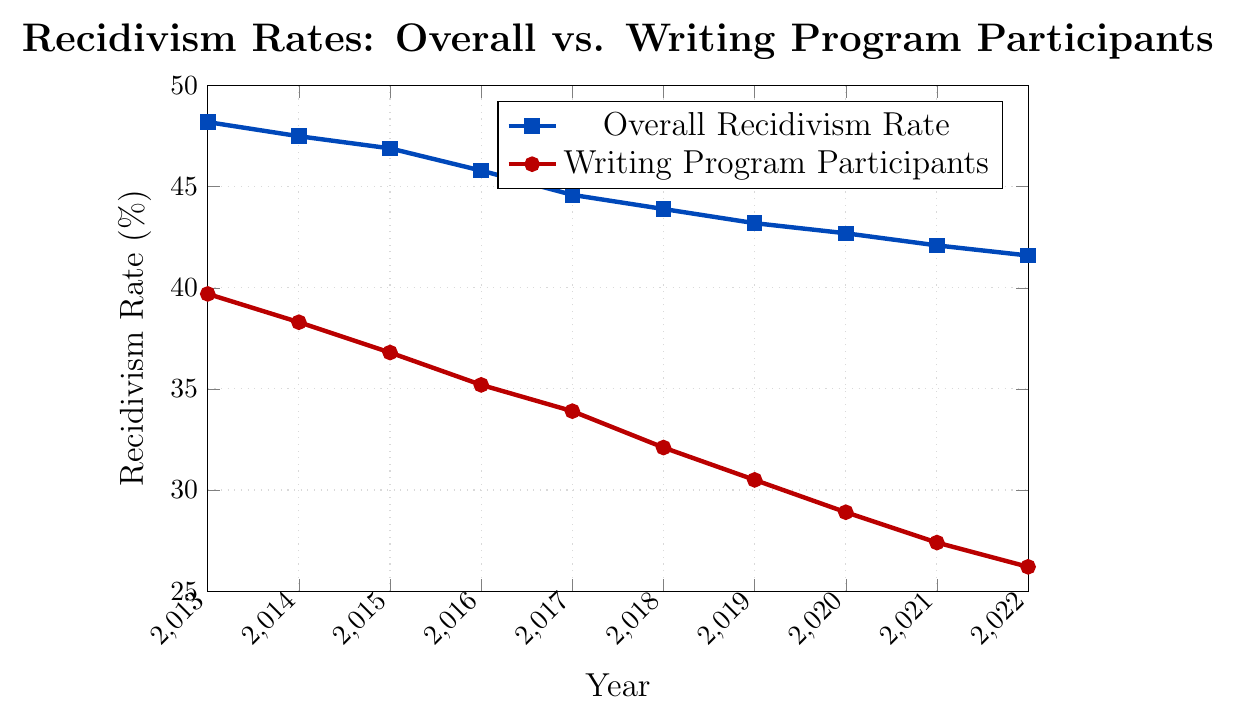What's the difference in recidivism rate between the two groups in 2022? First, find the recidivism rate for overall individuals in 2022, which is 41.6%. Then, find the rate for writing program participants in 2022, which is 26.2%. Subtract the latter from the former: 41.6% - 26.2% = 15.4%.
Answer: 15.4% In which year is the gap between the overall recidivism rate and the rate for writing program participants the smallest? First, calculate the differences for each year:
2013: 48.2 - 39.7 = 8.5%
2014: 47.5 - 38.3 = 9.2%
2015: 46.9 - 36.8 = 10.1%
2016: 45.8 - 35.2 = 10.6%
2017: 44.6 - 33.9 = 10.7%
2018: 43.9 - 32.1 = 11.8%
2019: 43.2 - 30.5 = 12.7%
2020: 42.7 - 28.9 = 13.8%
2021: 42.1 - 27.4 = 14.7%
2022: 41.6 - 26.2 = 15.4%
The smallest gap is in 2013, which is 8.5%.
Answer: 2013 By how much did the overall recidivism rate decrease from 2013 to 2022? Find the recidivism rate for overall individuals in 2013, which is 48.2%, and in 2022, which is 41.6%. Subtract 2022's rate from 2013's rate: 48.2% - 41.6% = 6.6%.
Answer: 6.6% What is the average recidivism rate for writing program participants from 2013 to 2022? Add all recidivism rates for writing program participants from 2013 to 2022 and divide by the number of years:
(39.7 + 38.3 + 36.8 + 35.2 + 33.9 + 32.1 + 30.5 + 28.9 + 27.4 + 26.2) / 10 = 32.9%.
Answer: 32.9% Which color represents the line for writing program participants? The line for writing program participants is red. Identify this from the color's description in the plot's legend.
Answer: Red How many percentage points did the recidivism rate for writing program participants drop from 2013 to 2018? Find the recidivism rate for writing program participants in 2013, which is 39.7%, and in 2018, which is 32.1%. Subtract 2018's rate from 2013's rate: 39.7% - 32.1% = 7.6%.
Answer: 7.6% In what year did the overall recidivism rate first drop below 45%? Locate the year when the overall recidivism rate is first recorded below 45%. This occurs in 2017 when the rate is 44.6%.
Answer: 2017 Compare the trends of the overall recidivism rate and the rate for writing program participants. Which group shows a steeper decline? By examining the slopes of both lines visually, notice that the gap between the highest and lowest values is larger for the writing program participants (39.7% to 26.2%) than for the overall group (48.2% to 41.6%). Thus, the line for writing program participants shows a steeper decline.
Answer: Writing program participants What is the ratio of the recidivism rate for writing program participants to the overall rate in 2022? Find the recidivism rate for writing program participants in 2022, which is 26.2%, and the overall rate in 2022, which is 41.6%. Divide the former by the latter to get the ratio: 26.2 / 41.6 ≈ 0.63.
Answer: 0.63 